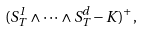<formula> <loc_0><loc_0><loc_500><loc_500>( S _ { T } ^ { 1 } \wedge \cdots \wedge S _ { T } ^ { d } - K ) ^ { + } ,</formula> 